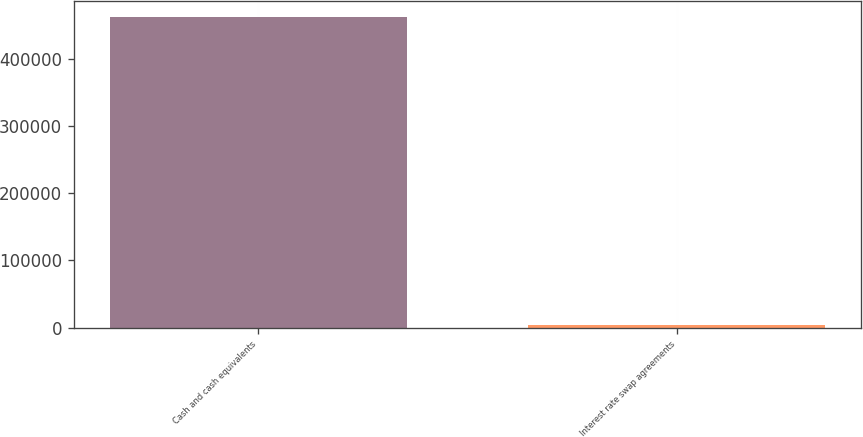<chart> <loc_0><loc_0><loc_500><loc_500><bar_chart><fcel>Cash and cash equivalents<fcel>Interest rate swap agreements<nl><fcel>462427<fcel>4345<nl></chart> 